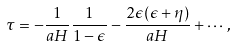Convert formula to latex. <formula><loc_0><loc_0><loc_500><loc_500>\tau = - \frac { 1 } { a H } \frac { 1 } { 1 - \epsilon } - \frac { 2 \epsilon ( \epsilon + \eta ) } { a H } + \cdots ,</formula> 